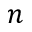Convert formula to latex. <formula><loc_0><loc_0><loc_500><loc_500>n</formula> 